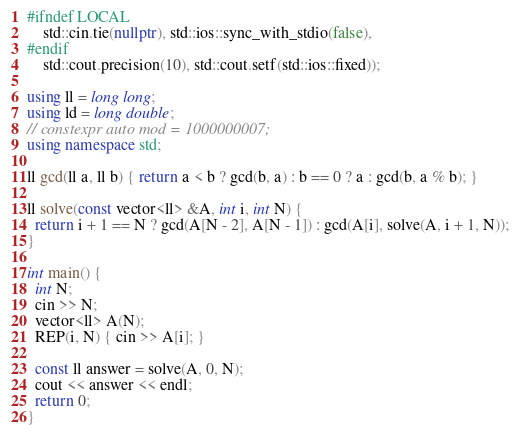<code> <loc_0><loc_0><loc_500><loc_500><_C++_>#ifndef LOCAL
    std::cin.tie(nullptr), std::ios::sync_with_stdio(false),
#endif
    std::cout.precision(10), std::cout.setf(std::ios::fixed));

using ll = long long;
using ld = long double;
// constexpr auto mod = 1000000007;
using namespace std;

ll gcd(ll a, ll b) { return a < b ? gcd(b, a) : b == 0 ? a : gcd(b, a % b); }

ll solve(const vector<ll> &A, int i, int N) {
  return i + 1 == N ? gcd(A[N - 2], A[N - 1]) : gcd(A[i], solve(A, i + 1, N));
}

int main() {
  int N;
  cin >> N;
  vector<ll> A(N);
  REP(i, N) { cin >> A[i]; }

  const ll answer = solve(A, 0, N);
  cout << answer << endl;
  return 0;
}
</code> 